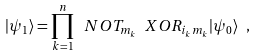Convert formula to latex. <formula><loc_0><loc_0><loc_500><loc_500>| \psi _ { 1 } \rangle = \prod _ { k = 1 } ^ { n } \ N O T _ { m _ { k } } \ X O R _ { i _ { k } m _ { k } } | \psi _ { 0 } \rangle \ ,</formula> 